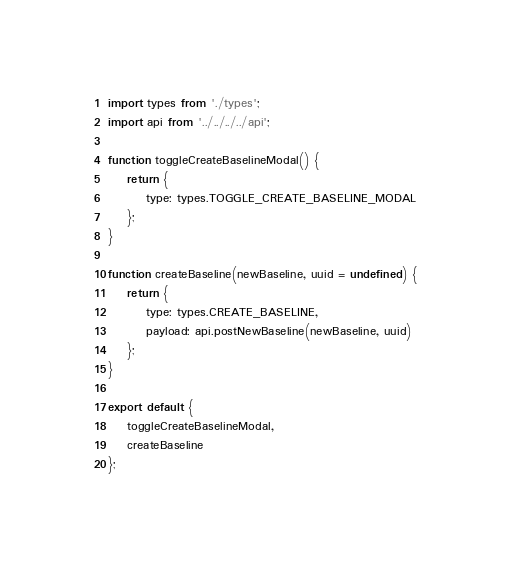<code> <loc_0><loc_0><loc_500><loc_500><_JavaScript_>import types from './types';
import api from '../../../../api';

function toggleCreateBaselineModal() {
    return {
        type: types.TOGGLE_CREATE_BASELINE_MODAL
    };
}

function createBaseline(newBaseline, uuid = undefined) {
    return {
        type: types.CREATE_BASELINE,
        payload: api.postNewBaseline(newBaseline, uuid)
    };
}

export default {
    toggleCreateBaselineModal,
    createBaseline
};
</code> 